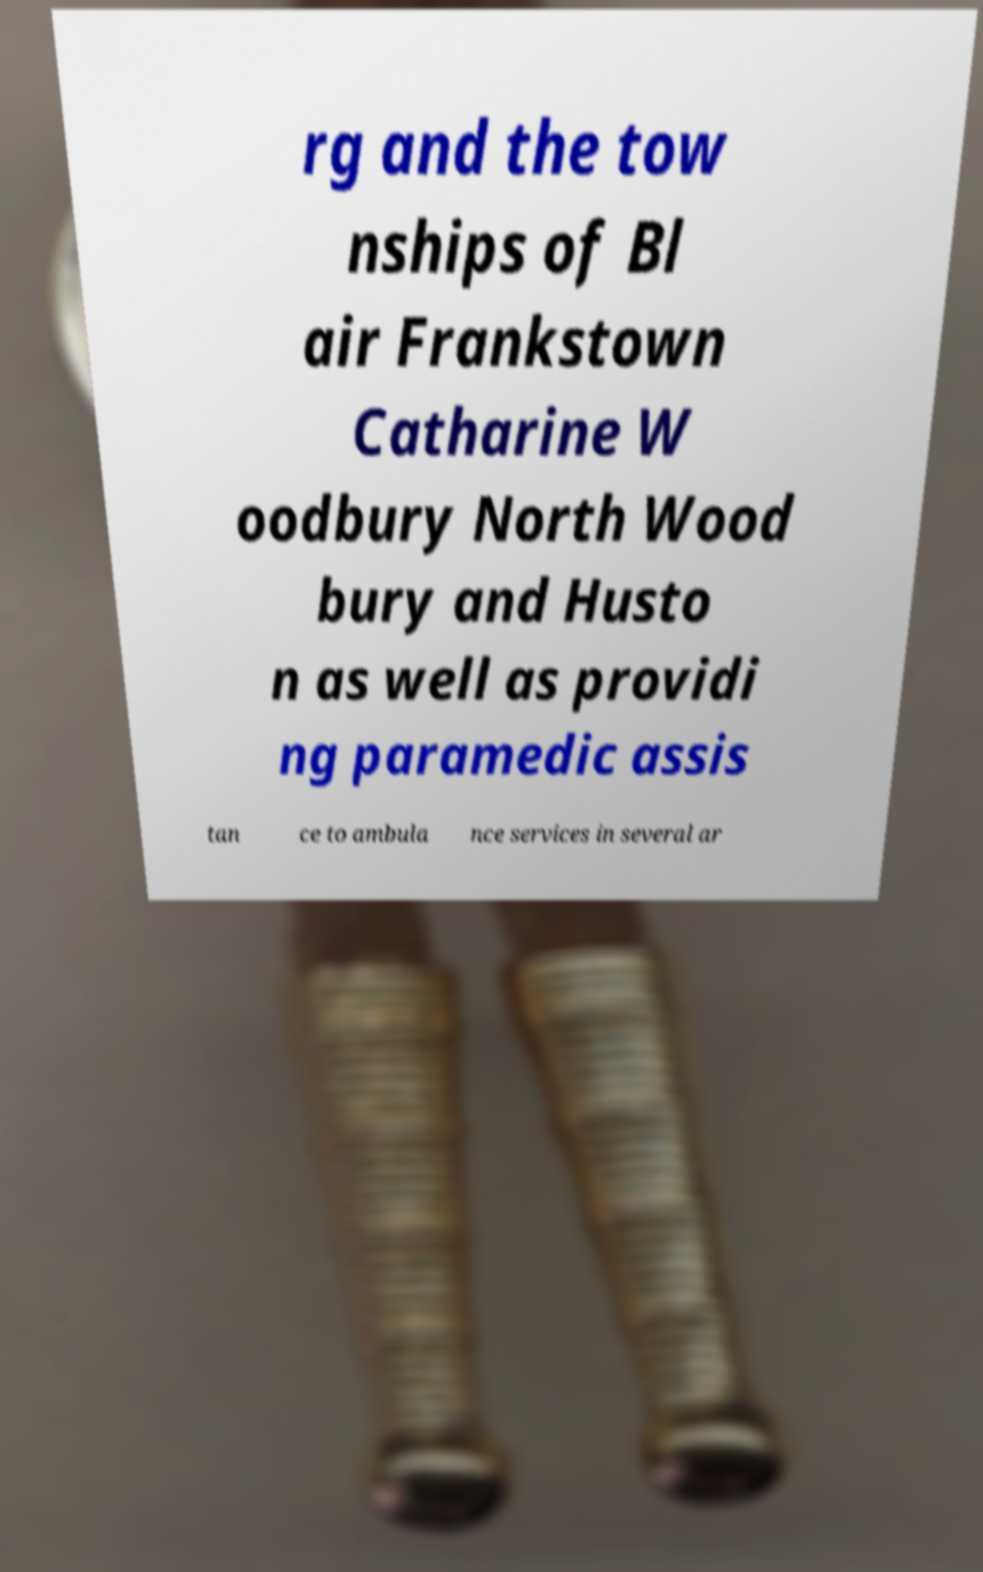Could you extract and type out the text from this image? rg and the tow nships of Bl air Frankstown Catharine W oodbury North Wood bury and Husto n as well as providi ng paramedic assis tan ce to ambula nce services in several ar 